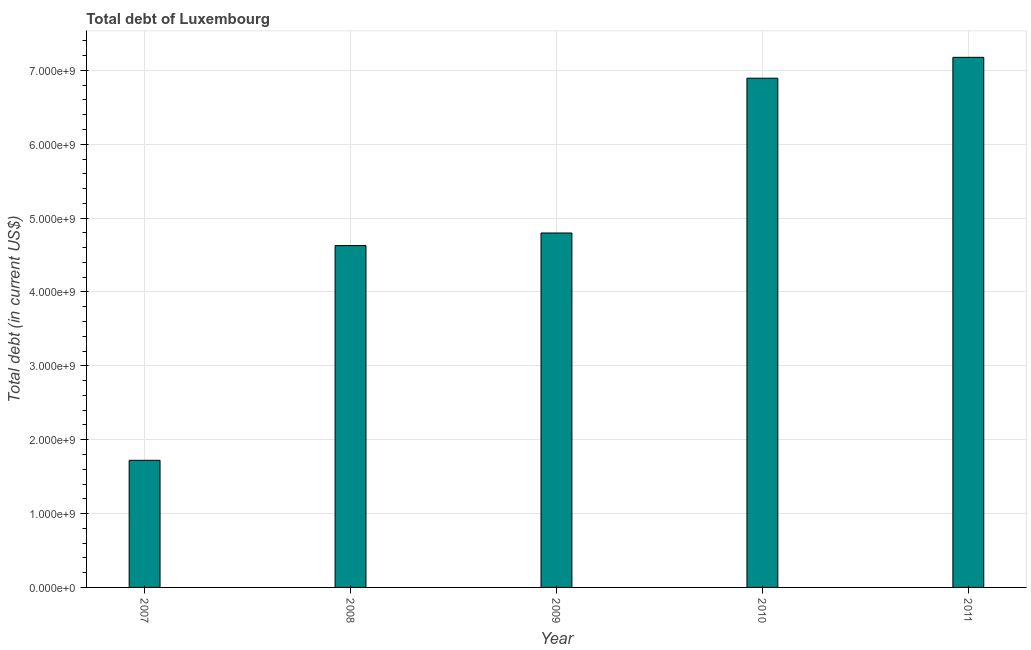What is the title of the graph?
Your answer should be compact. Total debt of Luxembourg. What is the label or title of the Y-axis?
Offer a very short reply. Total debt (in current US$). What is the total debt in 2009?
Provide a succinct answer. 4.80e+09. Across all years, what is the maximum total debt?
Offer a terse response. 7.18e+09. Across all years, what is the minimum total debt?
Provide a succinct answer. 1.72e+09. In which year was the total debt minimum?
Give a very brief answer. 2007. What is the sum of the total debt?
Offer a very short reply. 2.52e+1. What is the difference between the total debt in 2008 and 2010?
Your response must be concise. -2.27e+09. What is the average total debt per year?
Your answer should be compact. 5.04e+09. What is the median total debt?
Make the answer very short. 4.80e+09. Do a majority of the years between 2008 and 2011 (inclusive) have total debt greater than 6800000000 US$?
Your response must be concise. No. What is the ratio of the total debt in 2007 to that in 2009?
Ensure brevity in your answer.  0.36. Is the total debt in 2008 less than that in 2010?
Keep it short and to the point. Yes. What is the difference between the highest and the second highest total debt?
Ensure brevity in your answer.  2.83e+08. What is the difference between the highest and the lowest total debt?
Keep it short and to the point. 5.46e+09. Are all the bars in the graph horizontal?
Make the answer very short. No. Are the values on the major ticks of Y-axis written in scientific E-notation?
Your response must be concise. Yes. What is the Total debt (in current US$) in 2007?
Offer a very short reply. 1.72e+09. What is the Total debt (in current US$) of 2008?
Ensure brevity in your answer.  4.63e+09. What is the Total debt (in current US$) of 2009?
Keep it short and to the point. 4.80e+09. What is the Total debt (in current US$) of 2010?
Offer a very short reply. 6.89e+09. What is the Total debt (in current US$) of 2011?
Ensure brevity in your answer.  7.18e+09. What is the difference between the Total debt (in current US$) in 2007 and 2008?
Offer a terse response. -2.91e+09. What is the difference between the Total debt (in current US$) in 2007 and 2009?
Provide a short and direct response. -3.08e+09. What is the difference between the Total debt (in current US$) in 2007 and 2010?
Give a very brief answer. -5.17e+09. What is the difference between the Total debt (in current US$) in 2007 and 2011?
Provide a succinct answer. -5.46e+09. What is the difference between the Total debt (in current US$) in 2008 and 2009?
Make the answer very short. -1.70e+08. What is the difference between the Total debt (in current US$) in 2008 and 2010?
Offer a very short reply. -2.27e+09. What is the difference between the Total debt (in current US$) in 2008 and 2011?
Keep it short and to the point. -2.55e+09. What is the difference between the Total debt (in current US$) in 2009 and 2010?
Your response must be concise. -2.10e+09. What is the difference between the Total debt (in current US$) in 2009 and 2011?
Your answer should be compact. -2.38e+09. What is the difference between the Total debt (in current US$) in 2010 and 2011?
Offer a very short reply. -2.83e+08. What is the ratio of the Total debt (in current US$) in 2007 to that in 2008?
Provide a short and direct response. 0.37. What is the ratio of the Total debt (in current US$) in 2007 to that in 2009?
Your answer should be compact. 0.36. What is the ratio of the Total debt (in current US$) in 2007 to that in 2010?
Make the answer very short. 0.25. What is the ratio of the Total debt (in current US$) in 2007 to that in 2011?
Give a very brief answer. 0.24. What is the ratio of the Total debt (in current US$) in 2008 to that in 2010?
Your answer should be very brief. 0.67. What is the ratio of the Total debt (in current US$) in 2008 to that in 2011?
Give a very brief answer. 0.65. What is the ratio of the Total debt (in current US$) in 2009 to that in 2010?
Provide a short and direct response. 0.7. What is the ratio of the Total debt (in current US$) in 2009 to that in 2011?
Give a very brief answer. 0.67. What is the ratio of the Total debt (in current US$) in 2010 to that in 2011?
Provide a short and direct response. 0.96. 